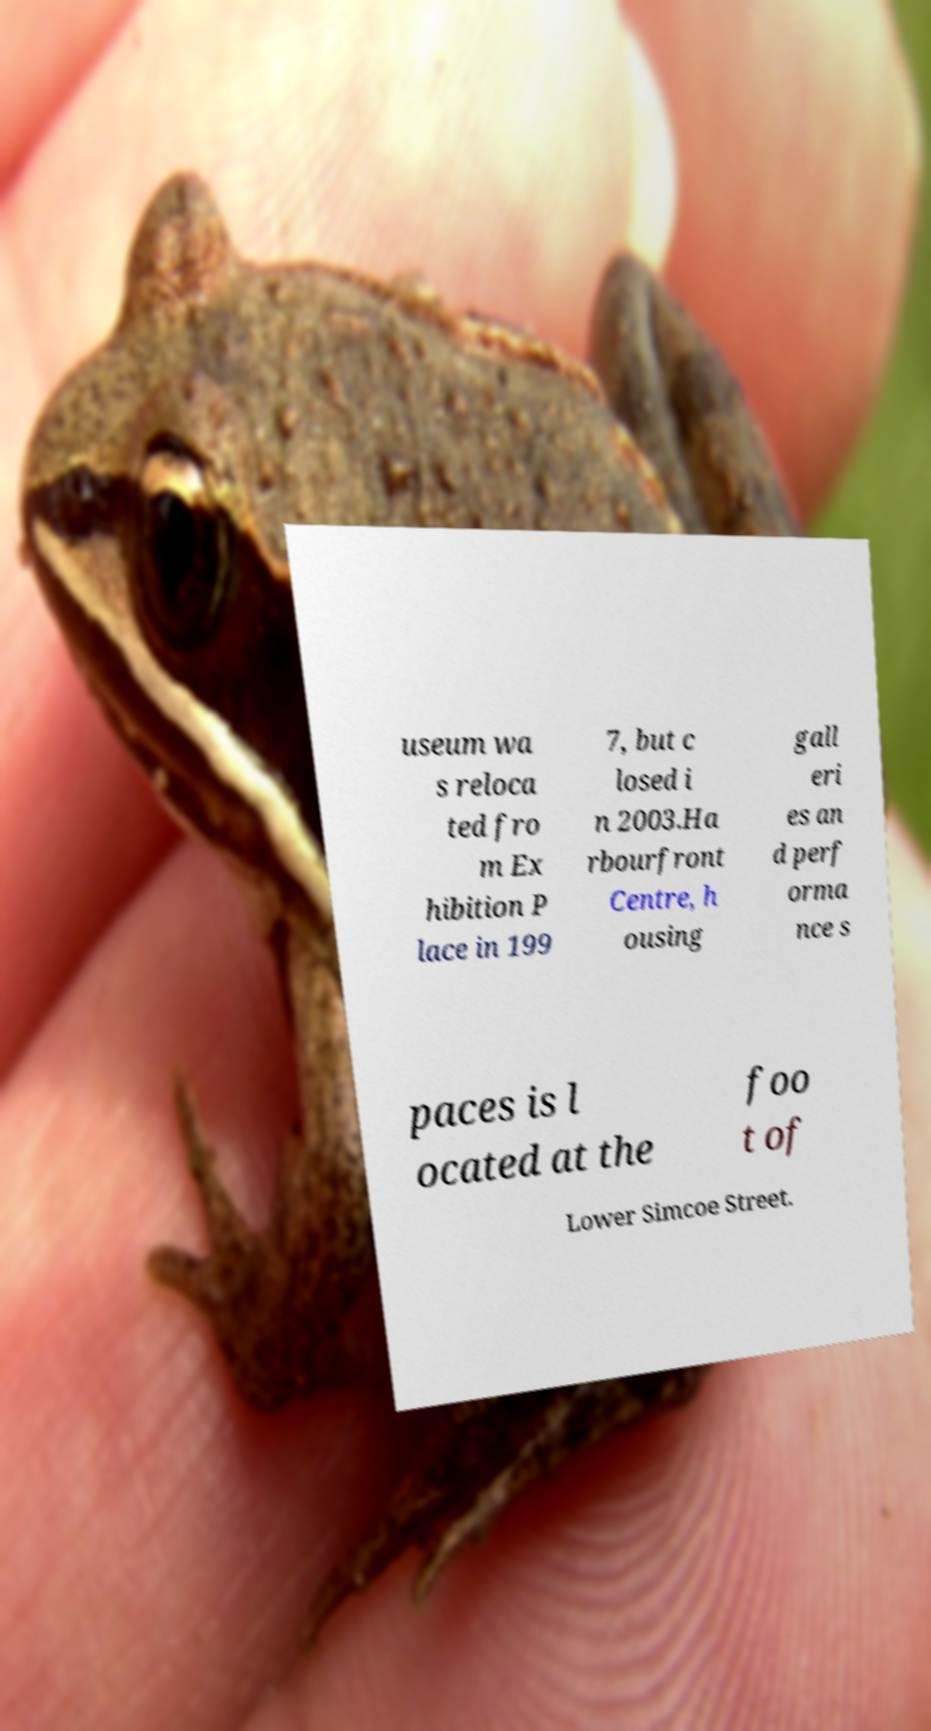There's text embedded in this image that I need extracted. Can you transcribe it verbatim? useum wa s reloca ted fro m Ex hibition P lace in 199 7, but c losed i n 2003.Ha rbourfront Centre, h ousing gall eri es an d perf orma nce s paces is l ocated at the foo t of Lower Simcoe Street. 